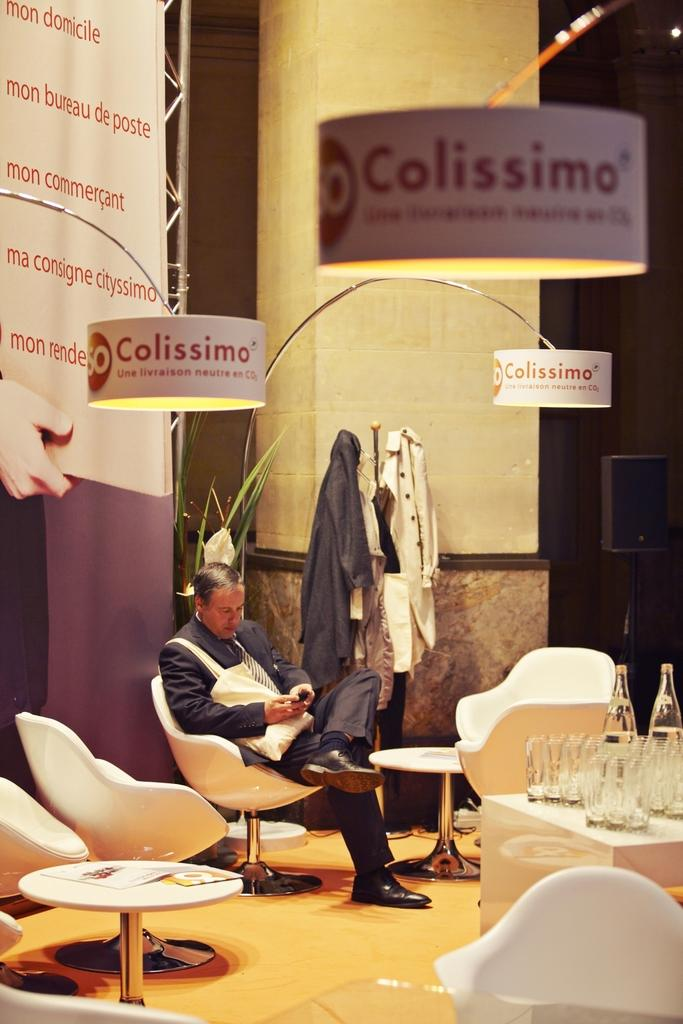What is the man in the image doing? The man is sitting in a chair. What objects are on the table in front of the man? There are glasses and bottles on the table in front of the man. What can be seen in the background of the image? There are coats, a wall, and a pillar visible in the background of the image. How many snails are crawling on the man's arm in the image? There are no snails visible in the image; the man's arm is not shown. What type of grape is the man eating in the image? There is no grape present in the image. 